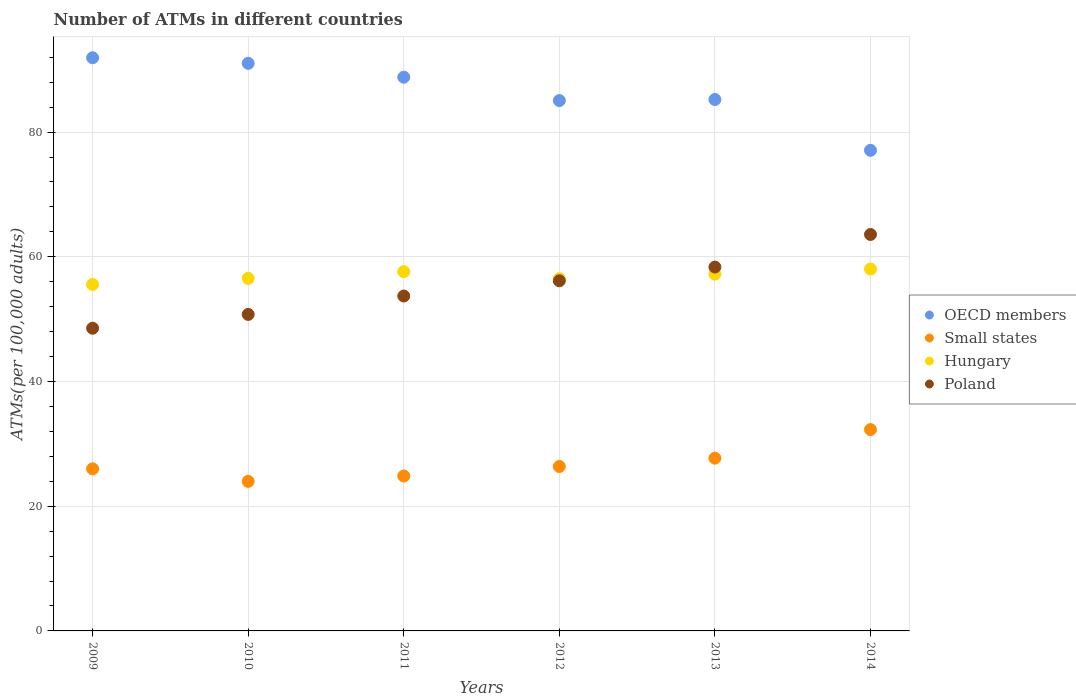Is the number of dotlines equal to the number of legend labels?
Offer a terse response. Yes. What is the number of ATMs in Hungary in 2010?
Provide a succinct answer. 56.55. Across all years, what is the maximum number of ATMs in Small states?
Your answer should be compact. 32.29. Across all years, what is the minimum number of ATMs in Hungary?
Make the answer very short. 55.56. In which year was the number of ATMs in OECD members maximum?
Give a very brief answer. 2009. In which year was the number of ATMs in OECD members minimum?
Offer a very short reply. 2014. What is the total number of ATMs in OECD members in the graph?
Keep it short and to the point. 519.12. What is the difference between the number of ATMs in Hungary in 2013 and that in 2014?
Provide a succinct answer. -0.82. What is the difference between the number of ATMs in Hungary in 2013 and the number of ATMs in OECD members in 2012?
Your response must be concise. -27.84. What is the average number of ATMs in Hungary per year?
Your answer should be compact. 56.91. In the year 2014, what is the difference between the number of ATMs in OECD members and number of ATMs in Hungary?
Give a very brief answer. 19.04. What is the ratio of the number of ATMs in Small states in 2012 to that in 2013?
Ensure brevity in your answer.  0.95. Is the number of ATMs in Poland in 2010 less than that in 2014?
Make the answer very short. Yes. Is the difference between the number of ATMs in OECD members in 2012 and 2014 greater than the difference between the number of ATMs in Hungary in 2012 and 2014?
Give a very brief answer. Yes. What is the difference between the highest and the second highest number of ATMs in Small states?
Make the answer very short. 4.58. What is the difference between the highest and the lowest number of ATMs in Poland?
Your answer should be very brief. 15.04. Is the sum of the number of ATMs in Poland in 2012 and 2013 greater than the maximum number of ATMs in Hungary across all years?
Provide a short and direct response. Yes. Is it the case that in every year, the sum of the number of ATMs in Poland and number of ATMs in Hungary  is greater than the number of ATMs in OECD members?
Your response must be concise. Yes. Does the number of ATMs in Small states monotonically increase over the years?
Ensure brevity in your answer.  No. Are the values on the major ticks of Y-axis written in scientific E-notation?
Keep it short and to the point. No. Does the graph contain any zero values?
Make the answer very short. No. Does the graph contain grids?
Offer a terse response. Yes. How are the legend labels stacked?
Ensure brevity in your answer.  Vertical. What is the title of the graph?
Provide a short and direct response. Number of ATMs in different countries. What is the label or title of the Y-axis?
Make the answer very short. ATMs(per 100,0 adults). What is the ATMs(per 100,000 adults) in OECD members in 2009?
Ensure brevity in your answer.  91.92. What is the ATMs(per 100,000 adults) of Small states in 2009?
Keep it short and to the point. 26. What is the ATMs(per 100,000 adults) in Hungary in 2009?
Provide a short and direct response. 55.56. What is the ATMs(per 100,000 adults) of Poland in 2009?
Ensure brevity in your answer.  48.54. What is the ATMs(per 100,000 adults) in OECD members in 2010?
Offer a terse response. 91.03. What is the ATMs(per 100,000 adults) of Small states in 2010?
Offer a very short reply. 23.99. What is the ATMs(per 100,000 adults) in Hungary in 2010?
Offer a very short reply. 56.55. What is the ATMs(per 100,000 adults) of Poland in 2010?
Make the answer very short. 50.76. What is the ATMs(per 100,000 adults) of OECD members in 2011?
Your answer should be compact. 88.81. What is the ATMs(per 100,000 adults) in Small states in 2011?
Provide a short and direct response. 24.84. What is the ATMs(per 100,000 adults) of Hungary in 2011?
Ensure brevity in your answer.  57.63. What is the ATMs(per 100,000 adults) in Poland in 2011?
Ensure brevity in your answer.  53.71. What is the ATMs(per 100,000 adults) of OECD members in 2012?
Provide a short and direct response. 85.06. What is the ATMs(per 100,000 adults) in Small states in 2012?
Your answer should be very brief. 26.37. What is the ATMs(per 100,000 adults) of Hungary in 2012?
Give a very brief answer. 56.49. What is the ATMs(per 100,000 adults) of Poland in 2012?
Give a very brief answer. 56.16. What is the ATMs(per 100,000 adults) of OECD members in 2013?
Offer a terse response. 85.23. What is the ATMs(per 100,000 adults) of Small states in 2013?
Keep it short and to the point. 27.7. What is the ATMs(per 100,000 adults) in Hungary in 2013?
Provide a succinct answer. 57.22. What is the ATMs(per 100,000 adults) in Poland in 2013?
Provide a short and direct response. 58.35. What is the ATMs(per 100,000 adults) in OECD members in 2014?
Make the answer very short. 77.08. What is the ATMs(per 100,000 adults) of Small states in 2014?
Make the answer very short. 32.29. What is the ATMs(per 100,000 adults) of Hungary in 2014?
Your response must be concise. 58.04. What is the ATMs(per 100,000 adults) of Poland in 2014?
Your answer should be very brief. 63.58. Across all years, what is the maximum ATMs(per 100,000 adults) in OECD members?
Provide a short and direct response. 91.92. Across all years, what is the maximum ATMs(per 100,000 adults) of Small states?
Your answer should be very brief. 32.29. Across all years, what is the maximum ATMs(per 100,000 adults) of Hungary?
Keep it short and to the point. 58.04. Across all years, what is the maximum ATMs(per 100,000 adults) of Poland?
Your response must be concise. 63.58. Across all years, what is the minimum ATMs(per 100,000 adults) of OECD members?
Your answer should be compact. 77.08. Across all years, what is the minimum ATMs(per 100,000 adults) of Small states?
Your response must be concise. 23.99. Across all years, what is the minimum ATMs(per 100,000 adults) in Hungary?
Keep it short and to the point. 55.56. Across all years, what is the minimum ATMs(per 100,000 adults) in Poland?
Offer a very short reply. 48.54. What is the total ATMs(per 100,000 adults) in OECD members in the graph?
Give a very brief answer. 519.12. What is the total ATMs(per 100,000 adults) of Small states in the graph?
Offer a very short reply. 161.19. What is the total ATMs(per 100,000 adults) of Hungary in the graph?
Your response must be concise. 341.49. What is the total ATMs(per 100,000 adults) of Poland in the graph?
Your response must be concise. 331.11. What is the difference between the ATMs(per 100,000 adults) of OECD members in 2009 and that in 2010?
Give a very brief answer. 0.89. What is the difference between the ATMs(per 100,000 adults) of Small states in 2009 and that in 2010?
Your response must be concise. 2.01. What is the difference between the ATMs(per 100,000 adults) in Hungary in 2009 and that in 2010?
Provide a succinct answer. -0.99. What is the difference between the ATMs(per 100,000 adults) in Poland in 2009 and that in 2010?
Your response must be concise. -2.22. What is the difference between the ATMs(per 100,000 adults) of OECD members in 2009 and that in 2011?
Provide a succinct answer. 3.12. What is the difference between the ATMs(per 100,000 adults) of Small states in 2009 and that in 2011?
Give a very brief answer. 1.15. What is the difference between the ATMs(per 100,000 adults) of Hungary in 2009 and that in 2011?
Your response must be concise. -2.07. What is the difference between the ATMs(per 100,000 adults) in Poland in 2009 and that in 2011?
Your answer should be very brief. -5.17. What is the difference between the ATMs(per 100,000 adults) of OECD members in 2009 and that in 2012?
Your response must be concise. 6.87. What is the difference between the ATMs(per 100,000 adults) of Small states in 2009 and that in 2012?
Make the answer very short. -0.38. What is the difference between the ATMs(per 100,000 adults) in Hungary in 2009 and that in 2012?
Your answer should be compact. -0.93. What is the difference between the ATMs(per 100,000 adults) in Poland in 2009 and that in 2012?
Provide a short and direct response. -7.61. What is the difference between the ATMs(per 100,000 adults) in OECD members in 2009 and that in 2013?
Your answer should be compact. 6.7. What is the difference between the ATMs(per 100,000 adults) in Small states in 2009 and that in 2013?
Provide a succinct answer. -1.71. What is the difference between the ATMs(per 100,000 adults) in Hungary in 2009 and that in 2013?
Give a very brief answer. -1.66. What is the difference between the ATMs(per 100,000 adults) in Poland in 2009 and that in 2013?
Your answer should be very brief. -9.81. What is the difference between the ATMs(per 100,000 adults) in OECD members in 2009 and that in 2014?
Offer a very short reply. 14.84. What is the difference between the ATMs(per 100,000 adults) of Small states in 2009 and that in 2014?
Your answer should be compact. -6.29. What is the difference between the ATMs(per 100,000 adults) of Hungary in 2009 and that in 2014?
Make the answer very short. -2.48. What is the difference between the ATMs(per 100,000 adults) in Poland in 2009 and that in 2014?
Your answer should be compact. -15.04. What is the difference between the ATMs(per 100,000 adults) in OECD members in 2010 and that in 2011?
Provide a short and direct response. 2.22. What is the difference between the ATMs(per 100,000 adults) in Small states in 2010 and that in 2011?
Your answer should be compact. -0.86. What is the difference between the ATMs(per 100,000 adults) in Hungary in 2010 and that in 2011?
Provide a succinct answer. -1.08. What is the difference between the ATMs(per 100,000 adults) of Poland in 2010 and that in 2011?
Give a very brief answer. -2.95. What is the difference between the ATMs(per 100,000 adults) of OECD members in 2010 and that in 2012?
Your answer should be very brief. 5.97. What is the difference between the ATMs(per 100,000 adults) of Small states in 2010 and that in 2012?
Offer a terse response. -2.39. What is the difference between the ATMs(per 100,000 adults) of Hungary in 2010 and that in 2012?
Give a very brief answer. 0.06. What is the difference between the ATMs(per 100,000 adults) in Poland in 2010 and that in 2012?
Keep it short and to the point. -5.39. What is the difference between the ATMs(per 100,000 adults) of OECD members in 2010 and that in 2013?
Your response must be concise. 5.8. What is the difference between the ATMs(per 100,000 adults) of Small states in 2010 and that in 2013?
Make the answer very short. -3.72. What is the difference between the ATMs(per 100,000 adults) in Hungary in 2010 and that in 2013?
Your response must be concise. -0.67. What is the difference between the ATMs(per 100,000 adults) of Poland in 2010 and that in 2013?
Provide a succinct answer. -7.59. What is the difference between the ATMs(per 100,000 adults) of OECD members in 2010 and that in 2014?
Make the answer very short. 13.95. What is the difference between the ATMs(per 100,000 adults) in Small states in 2010 and that in 2014?
Give a very brief answer. -8.3. What is the difference between the ATMs(per 100,000 adults) in Hungary in 2010 and that in 2014?
Your response must be concise. -1.49. What is the difference between the ATMs(per 100,000 adults) of Poland in 2010 and that in 2014?
Provide a short and direct response. -12.82. What is the difference between the ATMs(per 100,000 adults) of OECD members in 2011 and that in 2012?
Provide a short and direct response. 3.75. What is the difference between the ATMs(per 100,000 adults) of Small states in 2011 and that in 2012?
Ensure brevity in your answer.  -1.53. What is the difference between the ATMs(per 100,000 adults) in Hungary in 2011 and that in 2012?
Your response must be concise. 1.13. What is the difference between the ATMs(per 100,000 adults) of Poland in 2011 and that in 2012?
Your response must be concise. -2.45. What is the difference between the ATMs(per 100,000 adults) of OECD members in 2011 and that in 2013?
Your response must be concise. 3.58. What is the difference between the ATMs(per 100,000 adults) in Small states in 2011 and that in 2013?
Ensure brevity in your answer.  -2.86. What is the difference between the ATMs(per 100,000 adults) in Hungary in 2011 and that in 2013?
Give a very brief answer. 0.41. What is the difference between the ATMs(per 100,000 adults) in Poland in 2011 and that in 2013?
Offer a terse response. -4.64. What is the difference between the ATMs(per 100,000 adults) of OECD members in 2011 and that in 2014?
Your answer should be very brief. 11.72. What is the difference between the ATMs(per 100,000 adults) of Small states in 2011 and that in 2014?
Make the answer very short. -7.44. What is the difference between the ATMs(per 100,000 adults) in Hungary in 2011 and that in 2014?
Your answer should be very brief. -0.41. What is the difference between the ATMs(per 100,000 adults) of Poland in 2011 and that in 2014?
Provide a succinct answer. -9.87. What is the difference between the ATMs(per 100,000 adults) of OECD members in 2012 and that in 2013?
Give a very brief answer. -0.17. What is the difference between the ATMs(per 100,000 adults) of Small states in 2012 and that in 2013?
Provide a succinct answer. -1.33. What is the difference between the ATMs(per 100,000 adults) of Hungary in 2012 and that in 2013?
Your answer should be compact. -0.72. What is the difference between the ATMs(per 100,000 adults) in Poland in 2012 and that in 2013?
Give a very brief answer. -2.2. What is the difference between the ATMs(per 100,000 adults) in OECD members in 2012 and that in 2014?
Your answer should be very brief. 7.98. What is the difference between the ATMs(per 100,000 adults) in Small states in 2012 and that in 2014?
Offer a terse response. -5.92. What is the difference between the ATMs(per 100,000 adults) in Hungary in 2012 and that in 2014?
Ensure brevity in your answer.  -1.54. What is the difference between the ATMs(per 100,000 adults) in Poland in 2012 and that in 2014?
Offer a very short reply. -7.42. What is the difference between the ATMs(per 100,000 adults) of OECD members in 2013 and that in 2014?
Provide a short and direct response. 8.14. What is the difference between the ATMs(per 100,000 adults) of Small states in 2013 and that in 2014?
Keep it short and to the point. -4.58. What is the difference between the ATMs(per 100,000 adults) in Hungary in 2013 and that in 2014?
Your response must be concise. -0.82. What is the difference between the ATMs(per 100,000 adults) of Poland in 2013 and that in 2014?
Keep it short and to the point. -5.23. What is the difference between the ATMs(per 100,000 adults) in OECD members in 2009 and the ATMs(per 100,000 adults) in Small states in 2010?
Your answer should be very brief. 67.94. What is the difference between the ATMs(per 100,000 adults) of OECD members in 2009 and the ATMs(per 100,000 adults) of Hungary in 2010?
Offer a terse response. 35.37. What is the difference between the ATMs(per 100,000 adults) of OECD members in 2009 and the ATMs(per 100,000 adults) of Poland in 2010?
Your answer should be compact. 41.16. What is the difference between the ATMs(per 100,000 adults) in Small states in 2009 and the ATMs(per 100,000 adults) in Hungary in 2010?
Your answer should be compact. -30.56. What is the difference between the ATMs(per 100,000 adults) in Small states in 2009 and the ATMs(per 100,000 adults) in Poland in 2010?
Offer a terse response. -24.77. What is the difference between the ATMs(per 100,000 adults) of Hungary in 2009 and the ATMs(per 100,000 adults) of Poland in 2010?
Make the answer very short. 4.8. What is the difference between the ATMs(per 100,000 adults) of OECD members in 2009 and the ATMs(per 100,000 adults) of Small states in 2011?
Provide a succinct answer. 67.08. What is the difference between the ATMs(per 100,000 adults) in OECD members in 2009 and the ATMs(per 100,000 adults) in Hungary in 2011?
Provide a short and direct response. 34.3. What is the difference between the ATMs(per 100,000 adults) in OECD members in 2009 and the ATMs(per 100,000 adults) in Poland in 2011?
Make the answer very short. 38.21. What is the difference between the ATMs(per 100,000 adults) in Small states in 2009 and the ATMs(per 100,000 adults) in Hungary in 2011?
Offer a terse response. -31.63. What is the difference between the ATMs(per 100,000 adults) of Small states in 2009 and the ATMs(per 100,000 adults) of Poland in 2011?
Keep it short and to the point. -27.72. What is the difference between the ATMs(per 100,000 adults) of Hungary in 2009 and the ATMs(per 100,000 adults) of Poland in 2011?
Give a very brief answer. 1.85. What is the difference between the ATMs(per 100,000 adults) of OECD members in 2009 and the ATMs(per 100,000 adults) of Small states in 2012?
Keep it short and to the point. 65.55. What is the difference between the ATMs(per 100,000 adults) in OECD members in 2009 and the ATMs(per 100,000 adults) in Hungary in 2012?
Provide a succinct answer. 35.43. What is the difference between the ATMs(per 100,000 adults) of OECD members in 2009 and the ATMs(per 100,000 adults) of Poland in 2012?
Your response must be concise. 35.77. What is the difference between the ATMs(per 100,000 adults) in Small states in 2009 and the ATMs(per 100,000 adults) in Hungary in 2012?
Keep it short and to the point. -30.5. What is the difference between the ATMs(per 100,000 adults) of Small states in 2009 and the ATMs(per 100,000 adults) of Poland in 2012?
Keep it short and to the point. -30.16. What is the difference between the ATMs(per 100,000 adults) of Hungary in 2009 and the ATMs(per 100,000 adults) of Poland in 2012?
Offer a terse response. -0.6. What is the difference between the ATMs(per 100,000 adults) of OECD members in 2009 and the ATMs(per 100,000 adults) of Small states in 2013?
Your answer should be very brief. 64.22. What is the difference between the ATMs(per 100,000 adults) in OECD members in 2009 and the ATMs(per 100,000 adults) in Hungary in 2013?
Your response must be concise. 34.71. What is the difference between the ATMs(per 100,000 adults) in OECD members in 2009 and the ATMs(per 100,000 adults) in Poland in 2013?
Offer a very short reply. 33.57. What is the difference between the ATMs(per 100,000 adults) of Small states in 2009 and the ATMs(per 100,000 adults) of Hungary in 2013?
Make the answer very short. -31.22. What is the difference between the ATMs(per 100,000 adults) of Small states in 2009 and the ATMs(per 100,000 adults) of Poland in 2013?
Provide a short and direct response. -32.36. What is the difference between the ATMs(per 100,000 adults) in Hungary in 2009 and the ATMs(per 100,000 adults) in Poland in 2013?
Your response must be concise. -2.79. What is the difference between the ATMs(per 100,000 adults) of OECD members in 2009 and the ATMs(per 100,000 adults) of Small states in 2014?
Give a very brief answer. 59.64. What is the difference between the ATMs(per 100,000 adults) of OECD members in 2009 and the ATMs(per 100,000 adults) of Hungary in 2014?
Provide a succinct answer. 33.89. What is the difference between the ATMs(per 100,000 adults) of OECD members in 2009 and the ATMs(per 100,000 adults) of Poland in 2014?
Keep it short and to the point. 28.34. What is the difference between the ATMs(per 100,000 adults) of Small states in 2009 and the ATMs(per 100,000 adults) of Hungary in 2014?
Offer a terse response. -32.04. What is the difference between the ATMs(per 100,000 adults) of Small states in 2009 and the ATMs(per 100,000 adults) of Poland in 2014?
Provide a succinct answer. -37.59. What is the difference between the ATMs(per 100,000 adults) in Hungary in 2009 and the ATMs(per 100,000 adults) in Poland in 2014?
Your response must be concise. -8.02. What is the difference between the ATMs(per 100,000 adults) of OECD members in 2010 and the ATMs(per 100,000 adults) of Small states in 2011?
Your response must be concise. 66.19. What is the difference between the ATMs(per 100,000 adults) in OECD members in 2010 and the ATMs(per 100,000 adults) in Hungary in 2011?
Offer a terse response. 33.4. What is the difference between the ATMs(per 100,000 adults) of OECD members in 2010 and the ATMs(per 100,000 adults) of Poland in 2011?
Make the answer very short. 37.32. What is the difference between the ATMs(per 100,000 adults) in Small states in 2010 and the ATMs(per 100,000 adults) in Hungary in 2011?
Your answer should be compact. -33.64. What is the difference between the ATMs(per 100,000 adults) in Small states in 2010 and the ATMs(per 100,000 adults) in Poland in 2011?
Your response must be concise. -29.73. What is the difference between the ATMs(per 100,000 adults) of Hungary in 2010 and the ATMs(per 100,000 adults) of Poland in 2011?
Your answer should be very brief. 2.84. What is the difference between the ATMs(per 100,000 adults) of OECD members in 2010 and the ATMs(per 100,000 adults) of Small states in 2012?
Provide a succinct answer. 64.66. What is the difference between the ATMs(per 100,000 adults) of OECD members in 2010 and the ATMs(per 100,000 adults) of Hungary in 2012?
Ensure brevity in your answer.  34.54. What is the difference between the ATMs(per 100,000 adults) of OECD members in 2010 and the ATMs(per 100,000 adults) of Poland in 2012?
Keep it short and to the point. 34.87. What is the difference between the ATMs(per 100,000 adults) in Small states in 2010 and the ATMs(per 100,000 adults) in Hungary in 2012?
Your response must be concise. -32.51. What is the difference between the ATMs(per 100,000 adults) in Small states in 2010 and the ATMs(per 100,000 adults) in Poland in 2012?
Provide a succinct answer. -32.17. What is the difference between the ATMs(per 100,000 adults) of Hungary in 2010 and the ATMs(per 100,000 adults) of Poland in 2012?
Make the answer very short. 0.39. What is the difference between the ATMs(per 100,000 adults) in OECD members in 2010 and the ATMs(per 100,000 adults) in Small states in 2013?
Keep it short and to the point. 63.33. What is the difference between the ATMs(per 100,000 adults) of OECD members in 2010 and the ATMs(per 100,000 adults) of Hungary in 2013?
Offer a terse response. 33.81. What is the difference between the ATMs(per 100,000 adults) of OECD members in 2010 and the ATMs(per 100,000 adults) of Poland in 2013?
Make the answer very short. 32.68. What is the difference between the ATMs(per 100,000 adults) of Small states in 2010 and the ATMs(per 100,000 adults) of Hungary in 2013?
Make the answer very short. -33.23. What is the difference between the ATMs(per 100,000 adults) in Small states in 2010 and the ATMs(per 100,000 adults) in Poland in 2013?
Offer a terse response. -34.37. What is the difference between the ATMs(per 100,000 adults) of Hungary in 2010 and the ATMs(per 100,000 adults) of Poland in 2013?
Your answer should be very brief. -1.8. What is the difference between the ATMs(per 100,000 adults) of OECD members in 2010 and the ATMs(per 100,000 adults) of Small states in 2014?
Offer a very short reply. 58.74. What is the difference between the ATMs(per 100,000 adults) in OECD members in 2010 and the ATMs(per 100,000 adults) in Hungary in 2014?
Keep it short and to the point. 32.99. What is the difference between the ATMs(per 100,000 adults) of OECD members in 2010 and the ATMs(per 100,000 adults) of Poland in 2014?
Ensure brevity in your answer.  27.45. What is the difference between the ATMs(per 100,000 adults) of Small states in 2010 and the ATMs(per 100,000 adults) of Hungary in 2014?
Offer a very short reply. -34.05. What is the difference between the ATMs(per 100,000 adults) of Small states in 2010 and the ATMs(per 100,000 adults) of Poland in 2014?
Give a very brief answer. -39.6. What is the difference between the ATMs(per 100,000 adults) of Hungary in 2010 and the ATMs(per 100,000 adults) of Poland in 2014?
Ensure brevity in your answer.  -7.03. What is the difference between the ATMs(per 100,000 adults) in OECD members in 2011 and the ATMs(per 100,000 adults) in Small states in 2012?
Your answer should be compact. 62.43. What is the difference between the ATMs(per 100,000 adults) of OECD members in 2011 and the ATMs(per 100,000 adults) of Hungary in 2012?
Make the answer very short. 32.31. What is the difference between the ATMs(per 100,000 adults) in OECD members in 2011 and the ATMs(per 100,000 adults) in Poland in 2012?
Your answer should be very brief. 32.65. What is the difference between the ATMs(per 100,000 adults) in Small states in 2011 and the ATMs(per 100,000 adults) in Hungary in 2012?
Offer a very short reply. -31.65. What is the difference between the ATMs(per 100,000 adults) of Small states in 2011 and the ATMs(per 100,000 adults) of Poland in 2012?
Your answer should be very brief. -31.31. What is the difference between the ATMs(per 100,000 adults) of Hungary in 2011 and the ATMs(per 100,000 adults) of Poland in 2012?
Offer a very short reply. 1.47. What is the difference between the ATMs(per 100,000 adults) of OECD members in 2011 and the ATMs(per 100,000 adults) of Small states in 2013?
Offer a terse response. 61.1. What is the difference between the ATMs(per 100,000 adults) of OECD members in 2011 and the ATMs(per 100,000 adults) of Hungary in 2013?
Provide a succinct answer. 31.59. What is the difference between the ATMs(per 100,000 adults) of OECD members in 2011 and the ATMs(per 100,000 adults) of Poland in 2013?
Offer a very short reply. 30.45. What is the difference between the ATMs(per 100,000 adults) of Small states in 2011 and the ATMs(per 100,000 adults) of Hungary in 2013?
Keep it short and to the point. -32.37. What is the difference between the ATMs(per 100,000 adults) in Small states in 2011 and the ATMs(per 100,000 adults) in Poland in 2013?
Offer a very short reply. -33.51. What is the difference between the ATMs(per 100,000 adults) in Hungary in 2011 and the ATMs(per 100,000 adults) in Poland in 2013?
Provide a short and direct response. -0.73. What is the difference between the ATMs(per 100,000 adults) in OECD members in 2011 and the ATMs(per 100,000 adults) in Small states in 2014?
Offer a very short reply. 56.52. What is the difference between the ATMs(per 100,000 adults) in OECD members in 2011 and the ATMs(per 100,000 adults) in Hungary in 2014?
Provide a short and direct response. 30.77. What is the difference between the ATMs(per 100,000 adults) in OECD members in 2011 and the ATMs(per 100,000 adults) in Poland in 2014?
Give a very brief answer. 25.22. What is the difference between the ATMs(per 100,000 adults) in Small states in 2011 and the ATMs(per 100,000 adults) in Hungary in 2014?
Your answer should be very brief. -33.19. What is the difference between the ATMs(per 100,000 adults) in Small states in 2011 and the ATMs(per 100,000 adults) in Poland in 2014?
Make the answer very short. -38.74. What is the difference between the ATMs(per 100,000 adults) in Hungary in 2011 and the ATMs(per 100,000 adults) in Poland in 2014?
Offer a very short reply. -5.95. What is the difference between the ATMs(per 100,000 adults) in OECD members in 2012 and the ATMs(per 100,000 adults) in Small states in 2013?
Ensure brevity in your answer.  57.35. What is the difference between the ATMs(per 100,000 adults) in OECD members in 2012 and the ATMs(per 100,000 adults) in Hungary in 2013?
Your answer should be compact. 27.84. What is the difference between the ATMs(per 100,000 adults) of OECD members in 2012 and the ATMs(per 100,000 adults) of Poland in 2013?
Provide a succinct answer. 26.7. What is the difference between the ATMs(per 100,000 adults) in Small states in 2012 and the ATMs(per 100,000 adults) in Hungary in 2013?
Offer a very short reply. -30.84. What is the difference between the ATMs(per 100,000 adults) in Small states in 2012 and the ATMs(per 100,000 adults) in Poland in 2013?
Give a very brief answer. -31.98. What is the difference between the ATMs(per 100,000 adults) in Hungary in 2012 and the ATMs(per 100,000 adults) in Poland in 2013?
Keep it short and to the point. -1.86. What is the difference between the ATMs(per 100,000 adults) in OECD members in 2012 and the ATMs(per 100,000 adults) in Small states in 2014?
Provide a succinct answer. 52.77. What is the difference between the ATMs(per 100,000 adults) in OECD members in 2012 and the ATMs(per 100,000 adults) in Hungary in 2014?
Ensure brevity in your answer.  27.02. What is the difference between the ATMs(per 100,000 adults) of OECD members in 2012 and the ATMs(per 100,000 adults) of Poland in 2014?
Your answer should be very brief. 21.48. What is the difference between the ATMs(per 100,000 adults) in Small states in 2012 and the ATMs(per 100,000 adults) in Hungary in 2014?
Provide a short and direct response. -31.67. What is the difference between the ATMs(per 100,000 adults) in Small states in 2012 and the ATMs(per 100,000 adults) in Poland in 2014?
Your response must be concise. -37.21. What is the difference between the ATMs(per 100,000 adults) in Hungary in 2012 and the ATMs(per 100,000 adults) in Poland in 2014?
Offer a terse response. -7.09. What is the difference between the ATMs(per 100,000 adults) of OECD members in 2013 and the ATMs(per 100,000 adults) of Small states in 2014?
Provide a succinct answer. 52.94. What is the difference between the ATMs(per 100,000 adults) in OECD members in 2013 and the ATMs(per 100,000 adults) in Hungary in 2014?
Keep it short and to the point. 27.19. What is the difference between the ATMs(per 100,000 adults) of OECD members in 2013 and the ATMs(per 100,000 adults) of Poland in 2014?
Offer a terse response. 21.64. What is the difference between the ATMs(per 100,000 adults) of Small states in 2013 and the ATMs(per 100,000 adults) of Hungary in 2014?
Provide a succinct answer. -30.34. What is the difference between the ATMs(per 100,000 adults) of Small states in 2013 and the ATMs(per 100,000 adults) of Poland in 2014?
Offer a terse response. -35.88. What is the difference between the ATMs(per 100,000 adults) in Hungary in 2013 and the ATMs(per 100,000 adults) in Poland in 2014?
Provide a succinct answer. -6.36. What is the average ATMs(per 100,000 adults) of OECD members per year?
Your answer should be compact. 86.52. What is the average ATMs(per 100,000 adults) in Small states per year?
Make the answer very short. 26.86. What is the average ATMs(per 100,000 adults) in Hungary per year?
Keep it short and to the point. 56.91. What is the average ATMs(per 100,000 adults) of Poland per year?
Make the answer very short. 55.19. In the year 2009, what is the difference between the ATMs(per 100,000 adults) in OECD members and ATMs(per 100,000 adults) in Small states?
Offer a terse response. 65.93. In the year 2009, what is the difference between the ATMs(per 100,000 adults) in OECD members and ATMs(per 100,000 adults) in Hungary?
Make the answer very short. 36.36. In the year 2009, what is the difference between the ATMs(per 100,000 adults) in OECD members and ATMs(per 100,000 adults) in Poland?
Offer a very short reply. 43.38. In the year 2009, what is the difference between the ATMs(per 100,000 adults) of Small states and ATMs(per 100,000 adults) of Hungary?
Keep it short and to the point. -29.56. In the year 2009, what is the difference between the ATMs(per 100,000 adults) of Small states and ATMs(per 100,000 adults) of Poland?
Offer a terse response. -22.55. In the year 2009, what is the difference between the ATMs(per 100,000 adults) in Hungary and ATMs(per 100,000 adults) in Poland?
Give a very brief answer. 7.02. In the year 2010, what is the difference between the ATMs(per 100,000 adults) of OECD members and ATMs(per 100,000 adults) of Small states?
Give a very brief answer. 67.04. In the year 2010, what is the difference between the ATMs(per 100,000 adults) of OECD members and ATMs(per 100,000 adults) of Hungary?
Your response must be concise. 34.48. In the year 2010, what is the difference between the ATMs(per 100,000 adults) of OECD members and ATMs(per 100,000 adults) of Poland?
Offer a very short reply. 40.27. In the year 2010, what is the difference between the ATMs(per 100,000 adults) in Small states and ATMs(per 100,000 adults) in Hungary?
Your answer should be very brief. -32.57. In the year 2010, what is the difference between the ATMs(per 100,000 adults) of Small states and ATMs(per 100,000 adults) of Poland?
Ensure brevity in your answer.  -26.78. In the year 2010, what is the difference between the ATMs(per 100,000 adults) in Hungary and ATMs(per 100,000 adults) in Poland?
Offer a very short reply. 5.79. In the year 2011, what is the difference between the ATMs(per 100,000 adults) of OECD members and ATMs(per 100,000 adults) of Small states?
Your answer should be very brief. 63.96. In the year 2011, what is the difference between the ATMs(per 100,000 adults) in OECD members and ATMs(per 100,000 adults) in Hungary?
Make the answer very short. 31.18. In the year 2011, what is the difference between the ATMs(per 100,000 adults) of OECD members and ATMs(per 100,000 adults) of Poland?
Give a very brief answer. 35.09. In the year 2011, what is the difference between the ATMs(per 100,000 adults) of Small states and ATMs(per 100,000 adults) of Hungary?
Offer a very short reply. -32.78. In the year 2011, what is the difference between the ATMs(per 100,000 adults) in Small states and ATMs(per 100,000 adults) in Poland?
Your answer should be very brief. -28.87. In the year 2011, what is the difference between the ATMs(per 100,000 adults) of Hungary and ATMs(per 100,000 adults) of Poland?
Keep it short and to the point. 3.92. In the year 2012, what is the difference between the ATMs(per 100,000 adults) in OECD members and ATMs(per 100,000 adults) in Small states?
Provide a short and direct response. 58.69. In the year 2012, what is the difference between the ATMs(per 100,000 adults) of OECD members and ATMs(per 100,000 adults) of Hungary?
Your response must be concise. 28.56. In the year 2012, what is the difference between the ATMs(per 100,000 adults) in OECD members and ATMs(per 100,000 adults) in Poland?
Your answer should be very brief. 28.9. In the year 2012, what is the difference between the ATMs(per 100,000 adults) of Small states and ATMs(per 100,000 adults) of Hungary?
Offer a terse response. -30.12. In the year 2012, what is the difference between the ATMs(per 100,000 adults) of Small states and ATMs(per 100,000 adults) of Poland?
Keep it short and to the point. -29.78. In the year 2012, what is the difference between the ATMs(per 100,000 adults) in Hungary and ATMs(per 100,000 adults) in Poland?
Keep it short and to the point. 0.34. In the year 2013, what is the difference between the ATMs(per 100,000 adults) of OECD members and ATMs(per 100,000 adults) of Small states?
Give a very brief answer. 57.52. In the year 2013, what is the difference between the ATMs(per 100,000 adults) in OECD members and ATMs(per 100,000 adults) in Hungary?
Provide a succinct answer. 28.01. In the year 2013, what is the difference between the ATMs(per 100,000 adults) of OECD members and ATMs(per 100,000 adults) of Poland?
Your response must be concise. 26.87. In the year 2013, what is the difference between the ATMs(per 100,000 adults) of Small states and ATMs(per 100,000 adults) of Hungary?
Ensure brevity in your answer.  -29.51. In the year 2013, what is the difference between the ATMs(per 100,000 adults) of Small states and ATMs(per 100,000 adults) of Poland?
Your answer should be compact. -30.65. In the year 2013, what is the difference between the ATMs(per 100,000 adults) of Hungary and ATMs(per 100,000 adults) of Poland?
Your answer should be compact. -1.14. In the year 2014, what is the difference between the ATMs(per 100,000 adults) in OECD members and ATMs(per 100,000 adults) in Small states?
Provide a short and direct response. 44.79. In the year 2014, what is the difference between the ATMs(per 100,000 adults) of OECD members and ATMs(per 100,000 adults) of Hungary?
Ensure brevity in your answer.  19.04. In the year 2014, what is the difference between the ATMs(per 100,000 adults) in OECD members and ATMs(per 100,000 adults) in Poland?
Your answer should be compact. 13.5. In the year 2014, what is the difference between the ATMs(per 100,000 adults) in Small states and ATMs(per 100,000 adults) in Hungary?
Give a very brief answer. -25.75. In the year 2014, what is the difference between the ATMs(per 100,000 adults) of Small states and ATMs(per 100,000 adults) of Poland?
Your answer should be very brief. -31.29. In the year 2014, what is the difference between the ATMs(per 100,000 adults) in Hungary and ATMs(per 100,000 adults) in Poland?
Make the answer very short. -5.54. What is the ratio of the ATMs(per 100,000 adults) of OECD members in 2009 to that in 2010?
Your answer should be compact. 1.01. What is the ratio of the ATMs(per 100,000 adults) of Small states in 2009 to that in 2010?
Keep it short and to the point. 1.08. What is the ratio of the ATMs(per 100,000 adults) of Hungary in 2009 to that in 2010?
Your answer should be very brief. 0.98. What is the ratio of the ATMs(per 100,000 adults) in Poland in 2009 to that in 2010?
Offer a terse response. 0.96. What is the ratio of the ATMs(per 100,000 adults) in OECD members in 2009 to that in 2011?
Offer a terse response. 1.04. What is the ratio of the ATMs(per 100,000 adults) in Small states in 2009 to that in 2011?
Your response must be concise. 1.05. What is the ratio of the ATMs(per 100,000 adults) of Hungary in 2009 to that in 2011?
Keep it short and to the point. 0.96. What is the ratio of the ATMs(per 100,000 adults) in Poland in 2009 to that in 2011?
Your response must be concise. 0.9. What is the ratio of the ATMs(per 100,000 adults) in OECD members in 2009 to that in 2012?
Offer a very short reply. 1.08. What is the ratio of the ATMs(per 100,000 adults) of Small states in 2009 to that in 2012?
Ensure brevity in your answer.  0.99. What is the ratio of the ATMs(per 100,000 adults) in Hungary in 2009 to that in 2012?
Provide a short and direct response. 0.98. What is the ratio of the ATMs(per 100,000 adults) in Poland in 2009 to that in 2012?
Your answer should be compact. 0.86. What is the ratio of the ATMs(per 100,000 adults) of OECD members in 2009 to that in 2013?
Offer a terse response. 1.08. What is the ratio of the ATMs(per 100,000 adults) of Small states in 2009 to that in 2013?
Offer a terse response. 0.94. What is the ratio of the ATMs(per 100,000 adults) in Hungary in 2009 to that in 2013?
Provide a succinct answer. 0.97. What is the ratio of the ATMs(per 100,000 adults) in Poland in 2009 to that in 2013?
Your response must be concise. 0.83. What is the ratio of the ATMs(per 100,000 adults) of OECD members in 2009 to that in 2014?
Provide a short and direct response. 1.19. What is the ratio of the ATMs(per 100,000 adults) in Small states in 2009 to that in 2014?
Provide a succinct answer. 0.81. What is the ratio of the ATMs(per 100,000 adults) in Hungary in 2009 to that in 2014?
Provide a succinct answer. 0.96. What is the ratio of the ATMs(per 100,000 adults) in Poland in 2009 to that in 2014?
Your answer should be compact. 0.76. What is the ratio of the ATMs(per 100,000 adults) of Small states in 2010 to that in 2011?
Offer a terse response. 0.97. What is the ratio of the ATMs(per 100,000 adults) of Hungary in 2010 to that in 2011?
Your answer should be very brief. 0.98. What is the ratio of the ATMs(per 100,000 adults) in Poland in 2010 to that in 2011?
Ensure brevity in your answer.  0.95. What is the ratio of the ATMs(per 100,000 adults) in OECD members in 2010 to that in 2012?
Provide a short and direct response. 1.07. What is the ratio of the ATMs(per 100,000 adults) of Small states in 2010 to that in 2012?
Make the answer very short. 0.91. What is the ratio of the ATMs(per 100,000 adults) in Hungary in 2010 to that in 2012?
Offer a terse response. 1. What is the ratio of the ATMs(per 100,000 adults) of Poland in 2010 to that in 2012?
Make the answer very short. 0.9. What is the ratio of the ATMs(per 100,000 adults) of OECD members in 2010 to that in 2013?
Offer a terse response. 1.07. What is the ratio of the ATMs(per 100,000 adults) of Small states in 2010 to that in 2013?
Give a very brief answer. 0.87. What is the ratio of the ATMs(per 100,000 adults) of Hungary in 2010 to that in 2013?
Provide a short and direct response. 0.99. What is the ratio of the ATMs(per 100,000 adults) of Poland in 2010 to that in 2013?
Make the answer very short. 0.87. What is the ratio of the ATMs(per 100,000 adults) of OECD members in 2010 to that in 2014?
Provide a succinct answer. 1.18. What is the ratio of the ATMs(per 100,000 adults) in Small states in 2010 to that in 2014?
Offer a terse response. 0.74. What is the ratio of the ATMs(per 100,000 adults) of Hungary in 2010 to that in 2014?
Your answer should be very brief. 0.97. What is the ratio of the ATMs(per 100,000 adults) of Poland in 2010 to that in 2014?
Provide a succinct answer. 0.8. What is the ratio of the ATMs(per 100,000 adults) of OECD members in 2011 to that in 2012?
Keep it short and to the point. 1.04. What is the ratio of the ATMs(per 100,000 adults) in Small states in 2011 to that in 2012?
Your answer should be very brief. 0.94. What is the ratio of the ATMs(per 100,000 adults) of Hungary in 2011 to that in 2012?
Provide a short and direct response. 1.02. What is the ratio of the ATMs(per 100,000 adults) of Poland in 2011 to that in 2012?
Offer a very short reply. 0.96. What is the ratio of the ATMs(per 100,000 adults) of OECD members in 2011 to that in 2013?
Make the answer very short. 1.04. What is the ratio of the ATMs(per 100,000 adults) of Small states in 2011 to that in 2013?
Your answer should be compact. 0.9. What is the ratio of the ATMs(per 100,000 adults) of Poland in 2011 to that in 2013?
Keep it short and to the point. 0.92. What is the ratio of the ATMs(per 100,000 adults) of OECD members in 2011 to that in 2014?
Give a very brief answer. 1.15. What is the ratio of the ATMs(per 100,000 adults) in Small states in 2011 to that in 2014?
Provide a succinct answer. 0.77. What is the ratio of the ATMs(per 100,000 adults) of Poland in 2011 to that in 2014?
Ensure brevity in your answer.  0.84. What is the ratio of the ATMs(per 100,000 adults) of OECD members in 2012 to that in 2013?
Ensure brevity in your answer.  1. What is the ratio of the ATMs(per 100,000 adults) of Small states in 2012 to that in 2013?
Make the answer very short. 0.95. What is the ratio of the ATMs(per 100,000 adults) of Hungary in 2012 to that in 2013?
Your answer should be very brief. 0.99. What is the ratio of the ATMs(per 100,000 adults) of Poland in 2012 to that in 2013?
Provide a succinct answer. 0.96. What is the ratio of the ATMs(per 100,000 adults) of OECD members in 2012 to that in 2014?
Offer a terse response. 1.1. What is the ratio of the ATMs(per 100,000 adults) of Small states in 2012 to that in 2014?
Make the answer very short. 0.82. What is the ratio of the ATMs(per 100,000 adults) in Hungary in 2012 to that in 2014?
Provide a succinct answer. 0.97. What is the ratio of the ATMs(per 100,000 adults) in Poland in 2012 to that in 2014?
Ensure brevity in your answer.  0.88. What is the ratio of the ATMs(per 100,000 adults) of OECD members in 2013 to that in 2014?
Offer a terse response. 1.11. What is the ratio of the ATMs(per 100,000 adults) in Small states in 2013 to that in 2014?
Offer a very short reply. 0.86. What is the ratio of the ATMs(per 100,000 adults) of Hungary in 2013 to that in 2014?
Your answer should be compact. 0.99. What is the ratio of the ATMs(per 100,000 adults) of Poland in 2013 to that in 2014?
Provide a succinct answer. 0.92. What is the difference between the highest and the second highest ATMs(per 100,000 adults) in OECD members?
Your answer should be very brief. 0.89. What is the difference between the highest and the second highest ATMs(per 100,000 adults) in Small states?
Provide a succinct answer. 4.58. What is the difference between the highest and the second highest ATMs(per 100,000 adults) in Hungary?
Offer a very short reply. 0.41. What is the difference between the highest and the second highest ATMs(per 100,000 adults) in Poland?
Keep it short and to the point. 5.23. What is the difference between the highest and the lowest ATMs(per 100,000 adults) in OECD members?
Your response must be concise. 14.84. What is the difference between the highest and the lowest ATMs(per 100,000 adults) of Small states?
Provide a short and direct response. 8.3. What is the difference between the highest and the lowest ATMs(per 100,000 adults) of Hungary?
Your response must be concise. 2.48. What is the difference between the highest and the lowest ATMs(per 100,000 adults) of Poland?
Your answer should be compact. 15.04. 